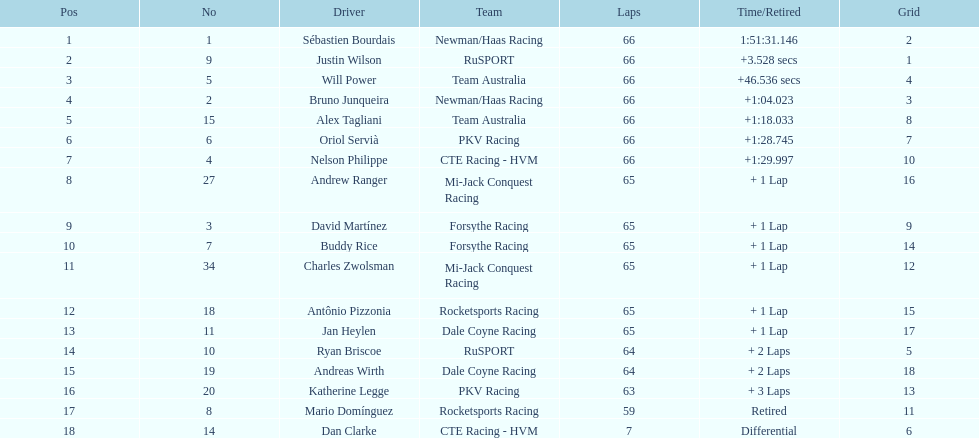Which teams participated in the 2006 gran premio telmex? Newman/Haas Racing, RuSPORT, Team Australia, Newman/Haas Racing, Team Australia, PKV Racing, CTE Racing - HVM, Mi-Jack Conquest Racing, Forsythe Racing, Forsythe Racing, Mi-Jack Conquest Racing, Rocketsports Racing, Dale Coyne Racing, RuSPORT, Dale Coyne Racing, PKV Racing, Rocketsports Racing, CTE Racing - HVM. Who were the drivers of these teams? Sébastien Bourdais, Justin Wilson, Will Power, Bruno Junqueira, Alex Tagliani, Oriol Servià, Nelson Philippe, Andrew Ranger, David Martínez, Buddy Rice, Charles Zwolsman, Antônio Pizzonia, Jan Heylen, Ryan Briscoe, Andreas Wirth, Katherine Legge, Mario Domínguez, Dan Clarke. Which driver finished last? Dan Clarke. 